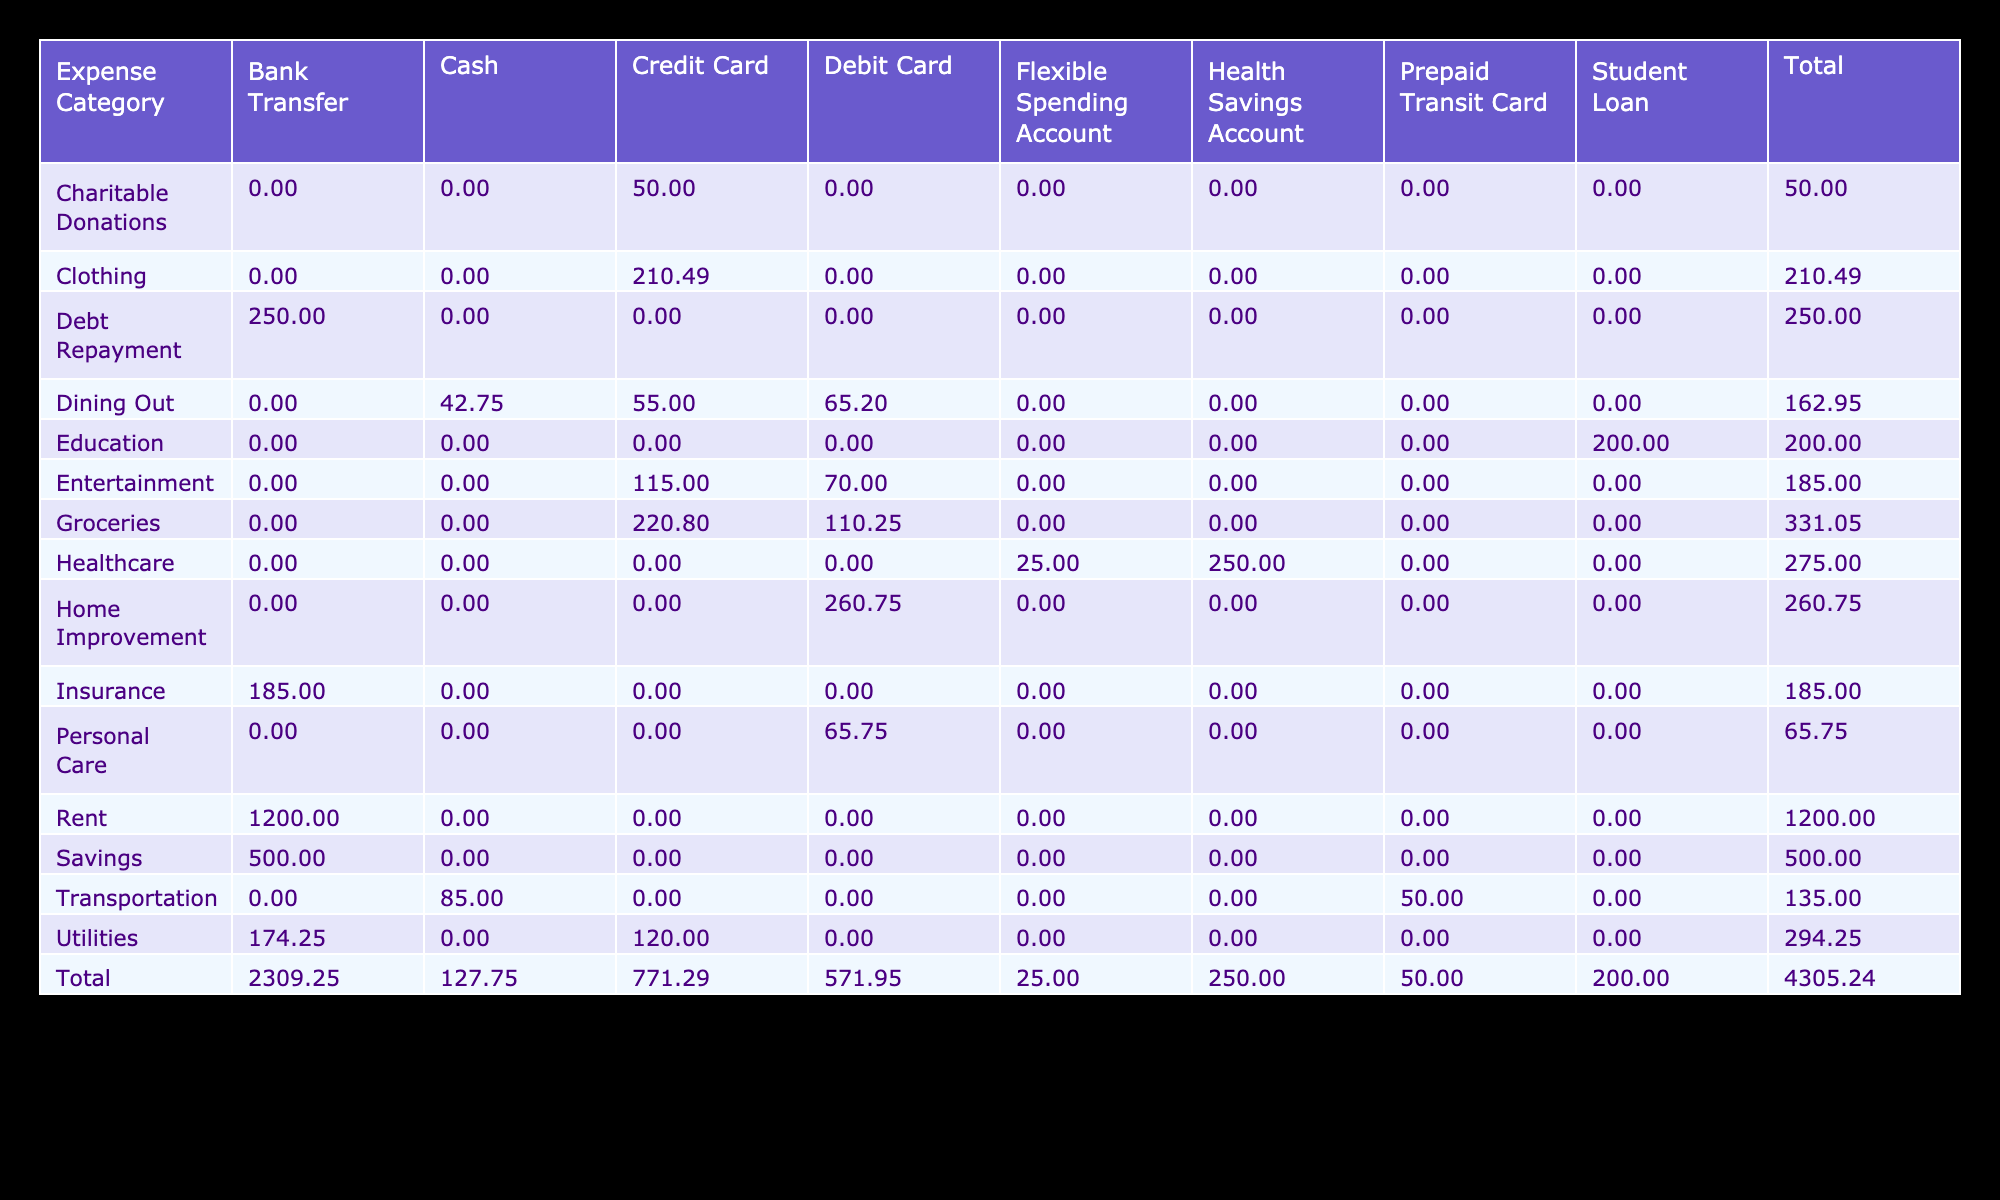What is the total amount spent on Groceries? To find the total spent on Groceries, I look at the Groceries row in the table and sum the amounts from each payment method: 125.50 (Credit Card) + 110.25 (Debit Card) + 95.30 (Credit Card) = 330.05.
Answer: 330.05 Which payment method was used for the highest expense category? I review the table for expenses listed by payment method. The highest expense category is Rent with an amount of 1200.00, which was paid using Bank Transfer.
Answer: Bank Transfer What percentage of the total amount is spent on Transportation? First, I find the total amount spent on all categories by summing all amounts: 125.50 + 98.75 + 65.20 + 45.00 + 80.00 + 150.00 + 1200.00 + 300.00 + 89.99 + 175.50 + 110.25 + 120.00 + 42.75 + 50.00 + 35.00 + 25.00 + 185.00 + 50.00 + 65.75 + 200.00 + 95.30 + 75.50 + 55.00 + 40.00 + 70.00 + 100.00 + 250.00 + 200.00 + 120.50 + 85.25 = 2857.00. The total spent on Transportation is 45.00 (Cash) + 50.00 (Prepaid Transit Card) + 40.00 (Cash) = 135.00. The percentage is (135.00 / 2857.00) * 100 = 4.72%.
Answer: 4.72% Is there a recurring expense for Dining Out? I check the Dining Out category in the table. There are three entries for Dining Out, all marked as 'No' for recurring, confirming that there is no recurring expense.
Answer: No What is the total spent on Entertainment, and how does it compare to Healthcare expenses? The total spent on Entertainment is calculated as 80.00 (Credit Card) + 35.00 (Credit Card) + 70.00 (Debit Card) = 185.00. Healthcare expenses are calculated as 150.00 (Health Savings Account) + 25.00 (Flexible Spending Account) + 100.00 (Health Savings Account) = 275.00. Since 185.00 (Entertainment) is less than 275.00 (Healthcare), Entertainment expenses are lower.
Answer: Entertainment is lower than Healthcare 